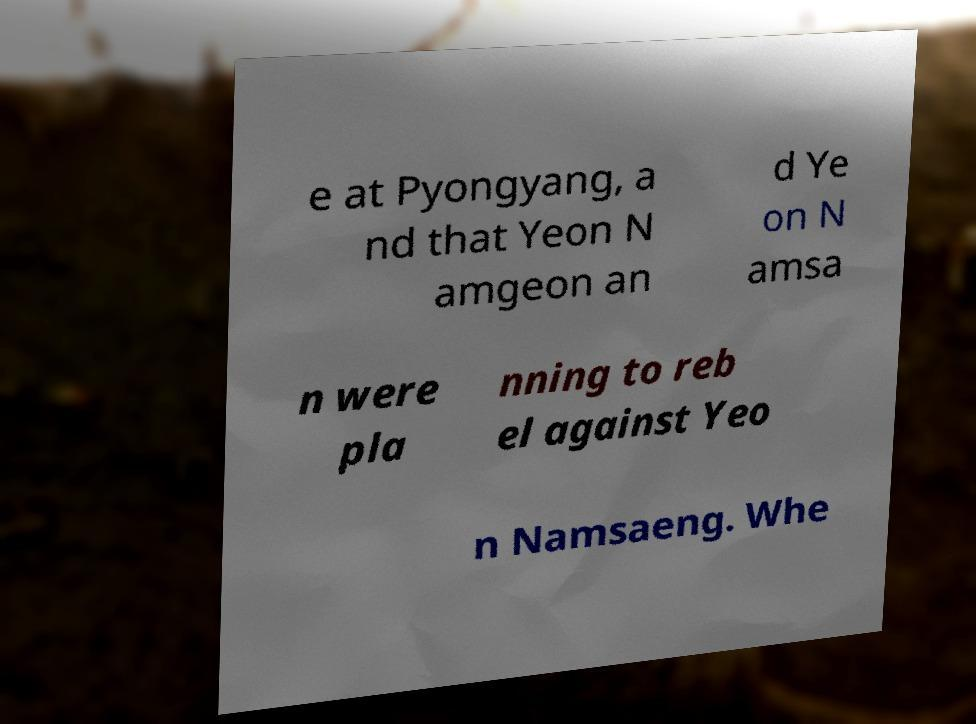I need the written content from this picture converted into text. Can you do that? e at Pyongyang, a nd that Yeon N amgeon an d Ye on N amsa n were pla nning to reb el against Yeo n Namsaeng. Whe 